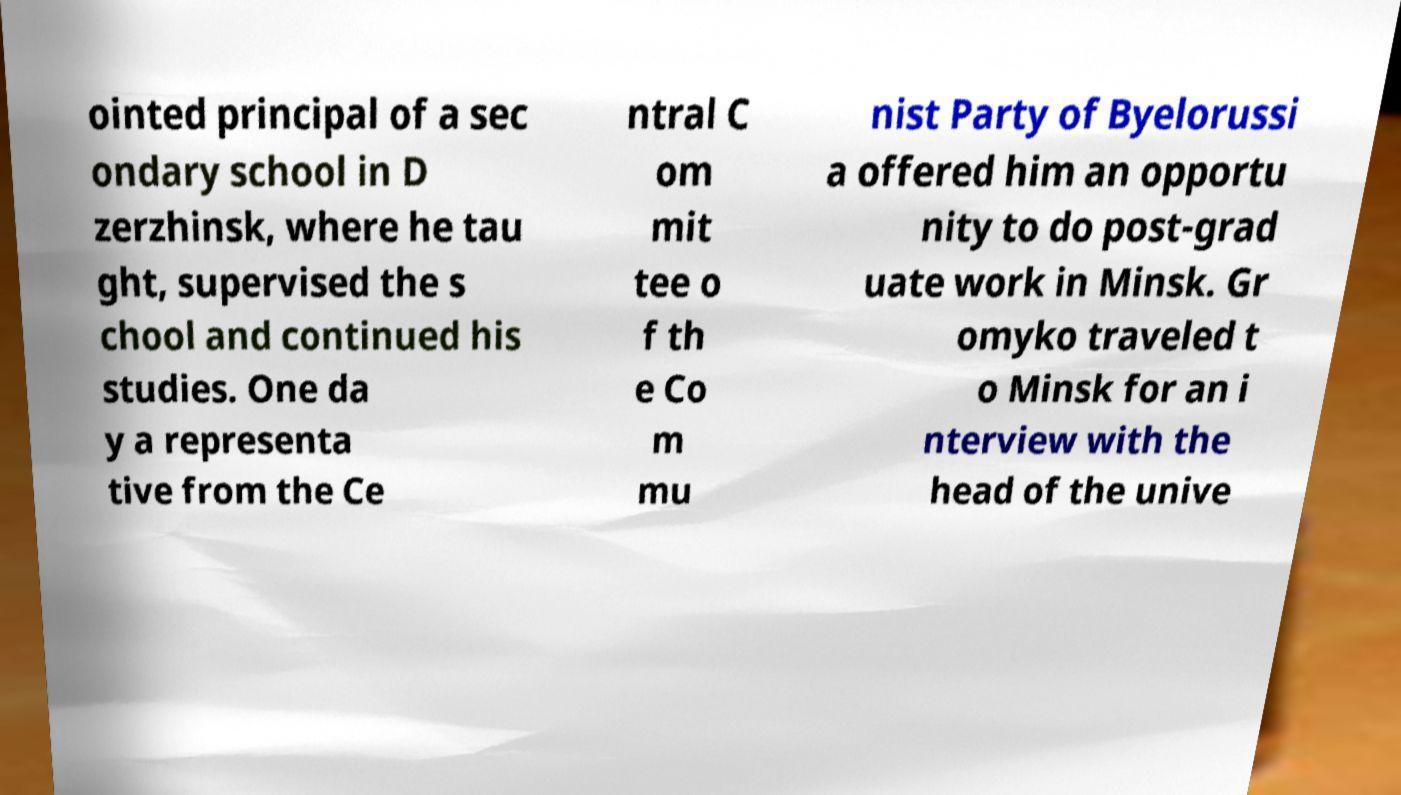Could you extract and type out the text from this image? ointed principal of a sec ondary school in D zerzhinsk, where he tau ght, supervised the s chool and continued his studies. One da y a representa tive from the Ce ntral C om mit tee o f th e Co m mu nist Party of Byelorussi a offered him an opportu nity to do post-grad uate work in Minsk. Gr omyko traveled t o Minsk for an i nterview with the head of the unive 